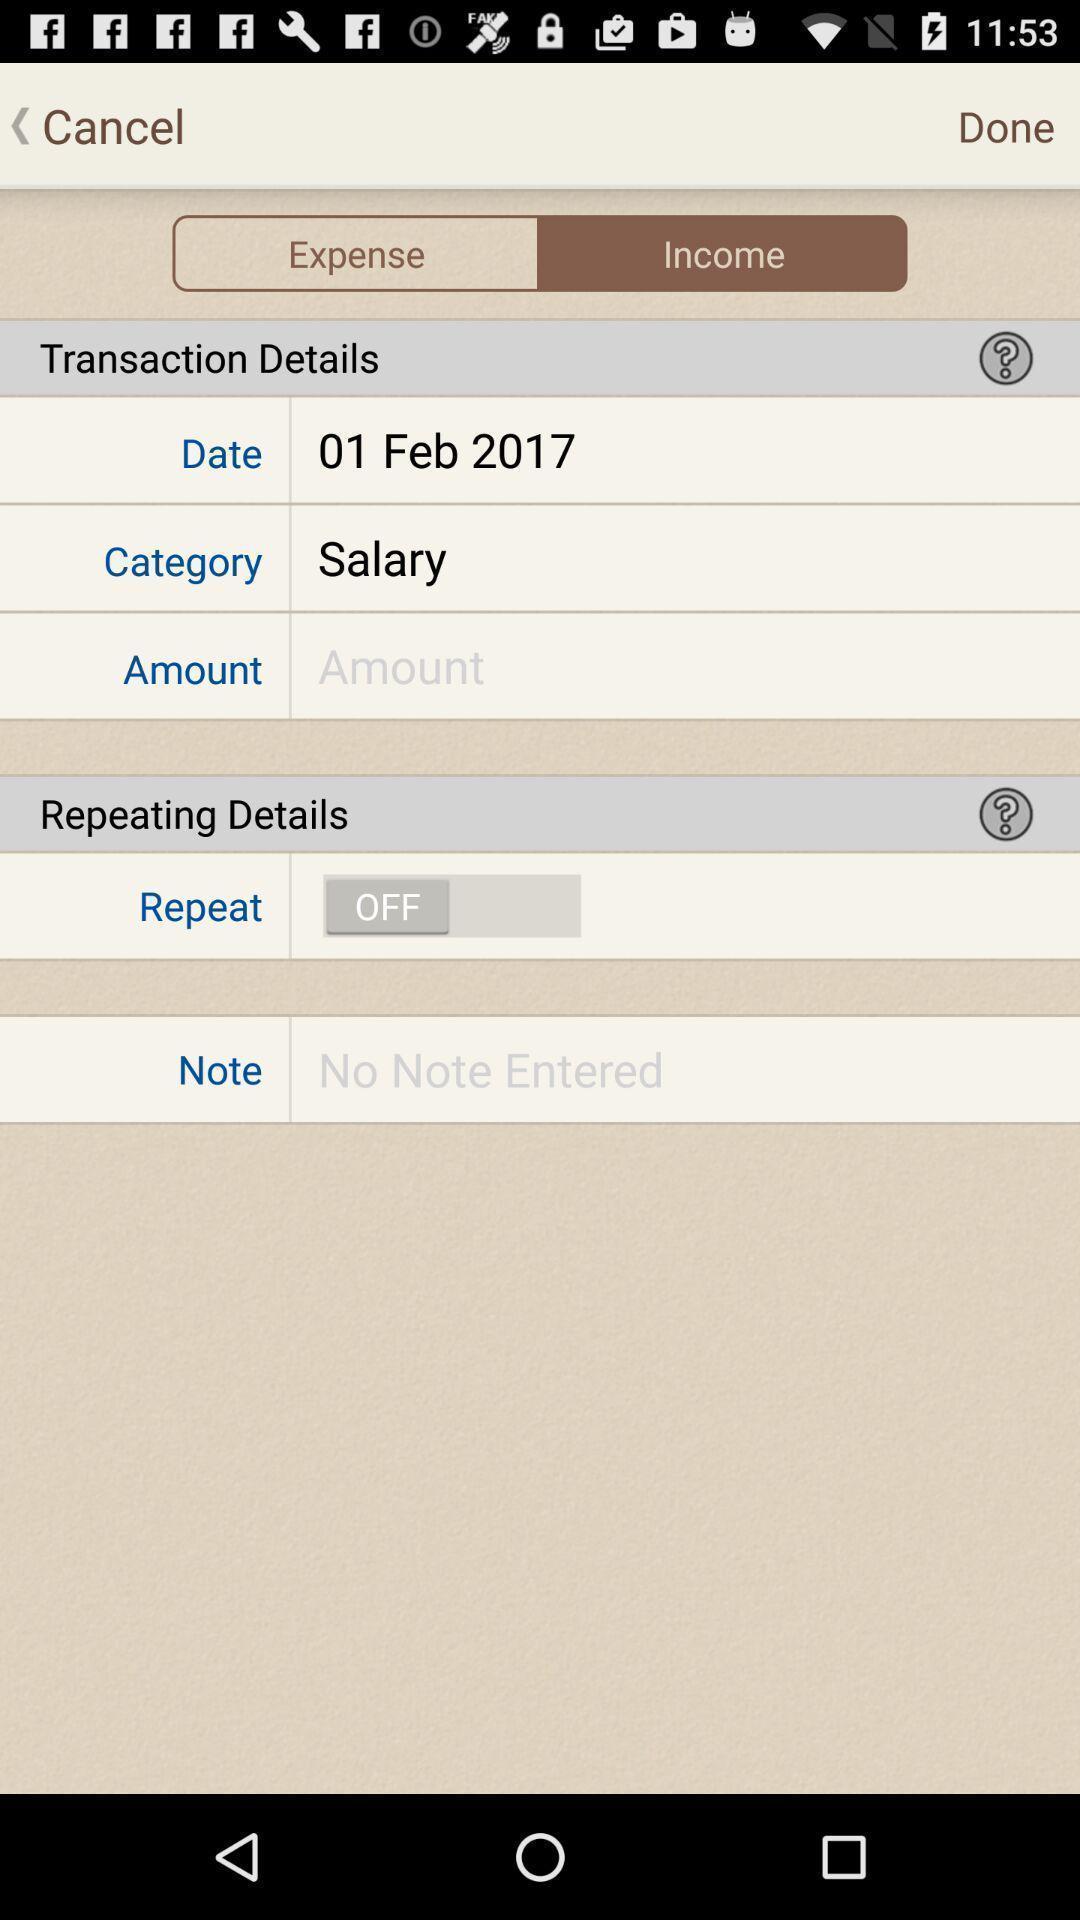What is the overall content of this screenshot? Screen showing few transaction details. 